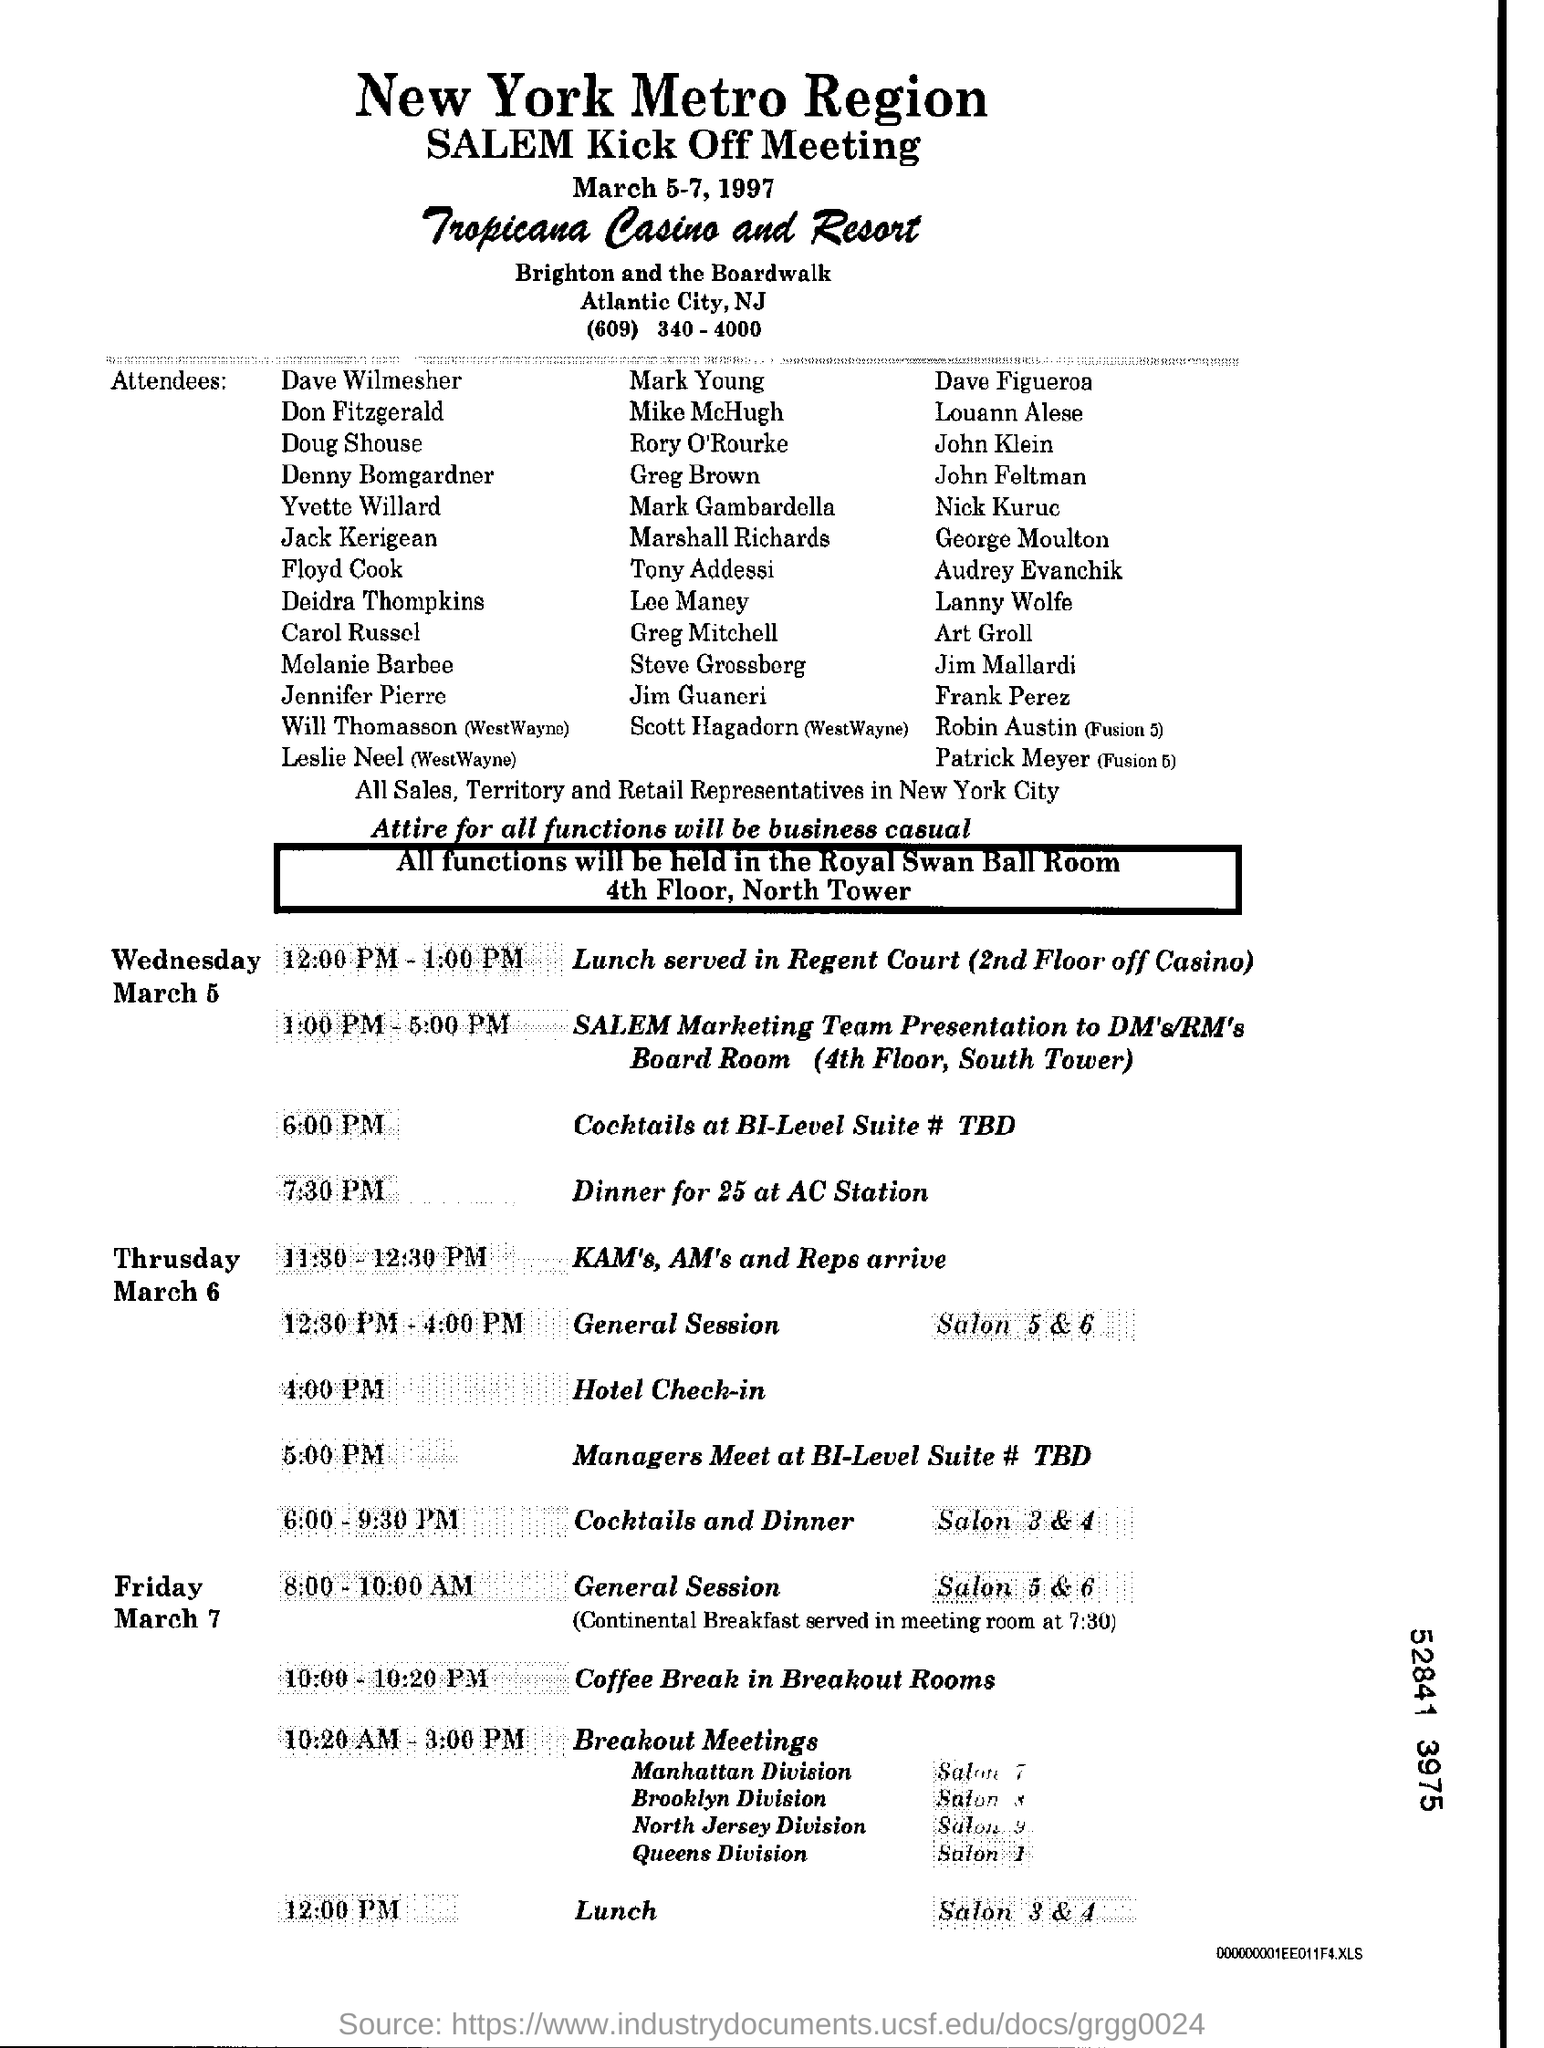What is the Lunch Time of Friday? As per the schedule displayed in the image for the 'New York Metro Region SALEM Kick Off Meeting' at the Tropicana Casino and Resort, the lunch time on Friday, March 7th, is set for 12:00 PM. This meal will serve as a break between the morning General Session and the afternoon Breakout Meetings. 